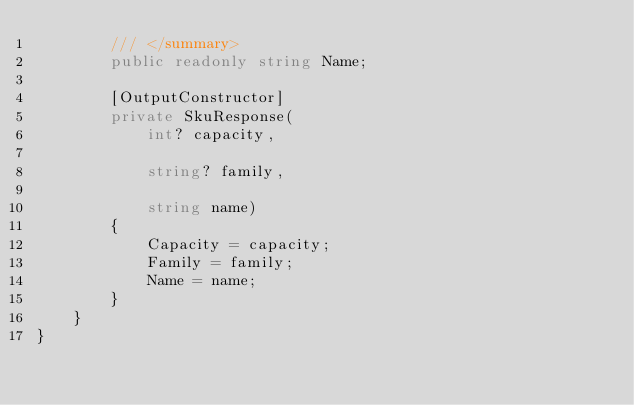<code> <loc_0><loc_0><loc_500><loc_500><_C#_>        /// </summary>
        public readonly string Name;

        [OutputConstructor]
        private SkuResponse(
            int? capacity,

            string? family,

            string name)
        {
            Capacity = capacity;
            Family = family;
            Name = name;
        }
    }
}
</code> 